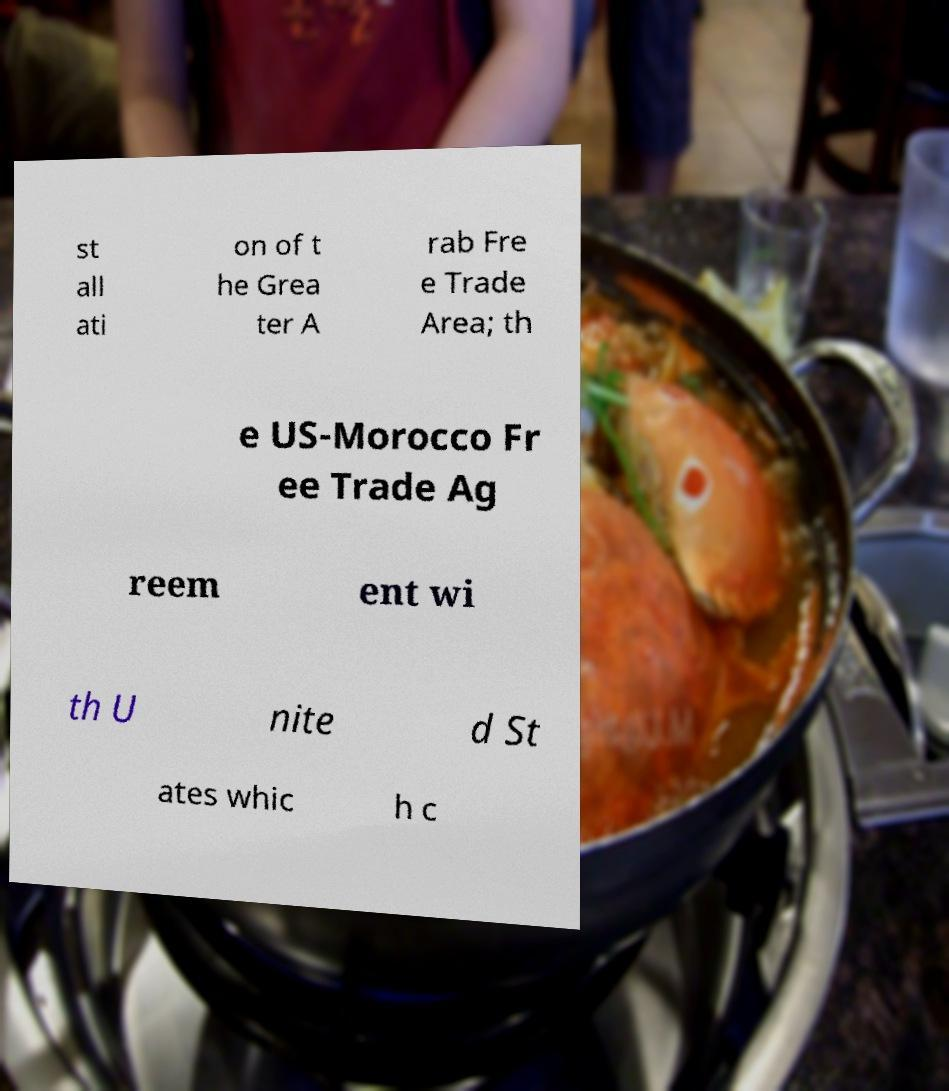I need the written content from this picture converted into text. Can you do that? st all ati on of t he Grea ter A rab Fre e Trade Area; th e US-Morocco Fr ee Trade Ag reem ent wi th U nite d St ates whic h c 